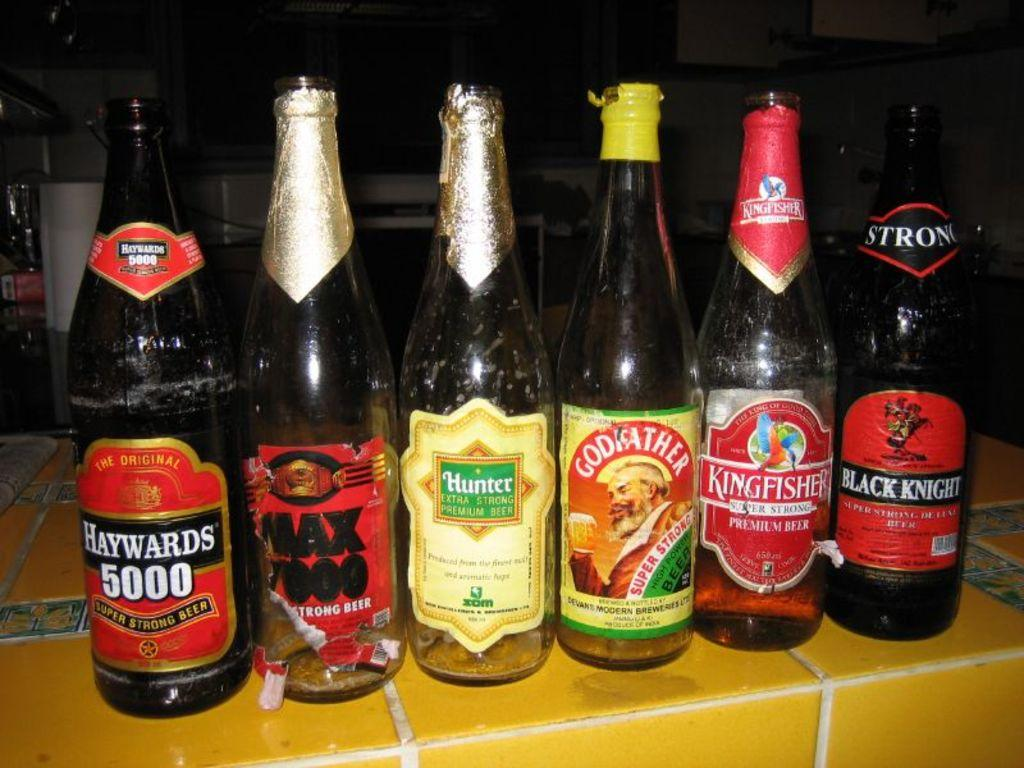<image>
Write a terse but informative summary of the picture. Six beer bottles are lined up and Haywards 5000 is at the far left. 